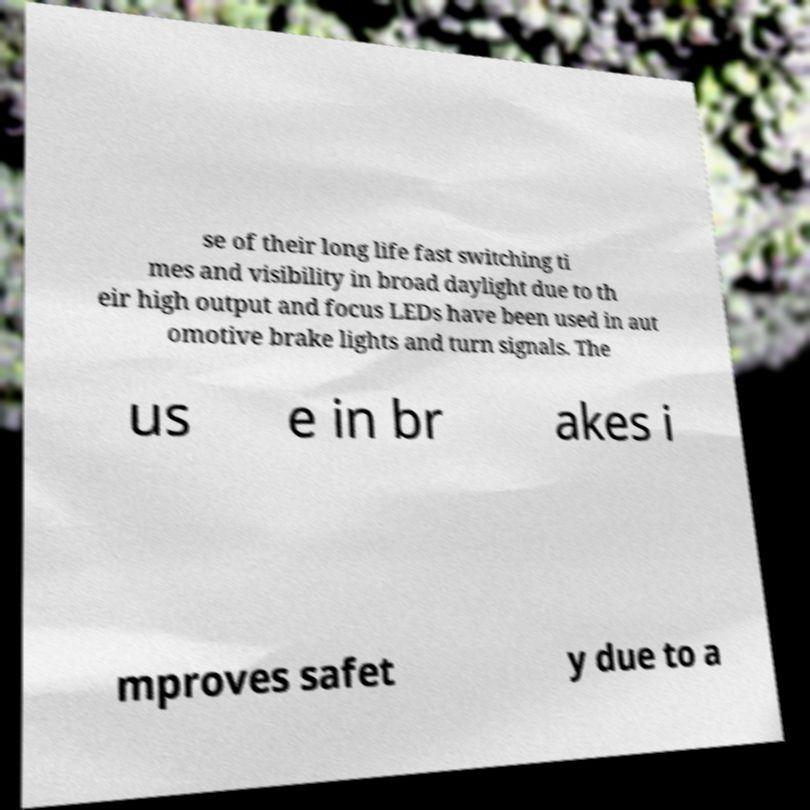Could you assist in decoding the text presented in this image and type it out clearly? se of their long life fast switching ti mes and visibility in broad daylight due to th eir high output and focus LEDs have been used in aut omotive brake lights and turn signals. The us e in br akes i mproves safet y due to a 